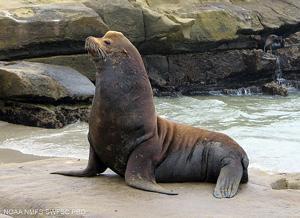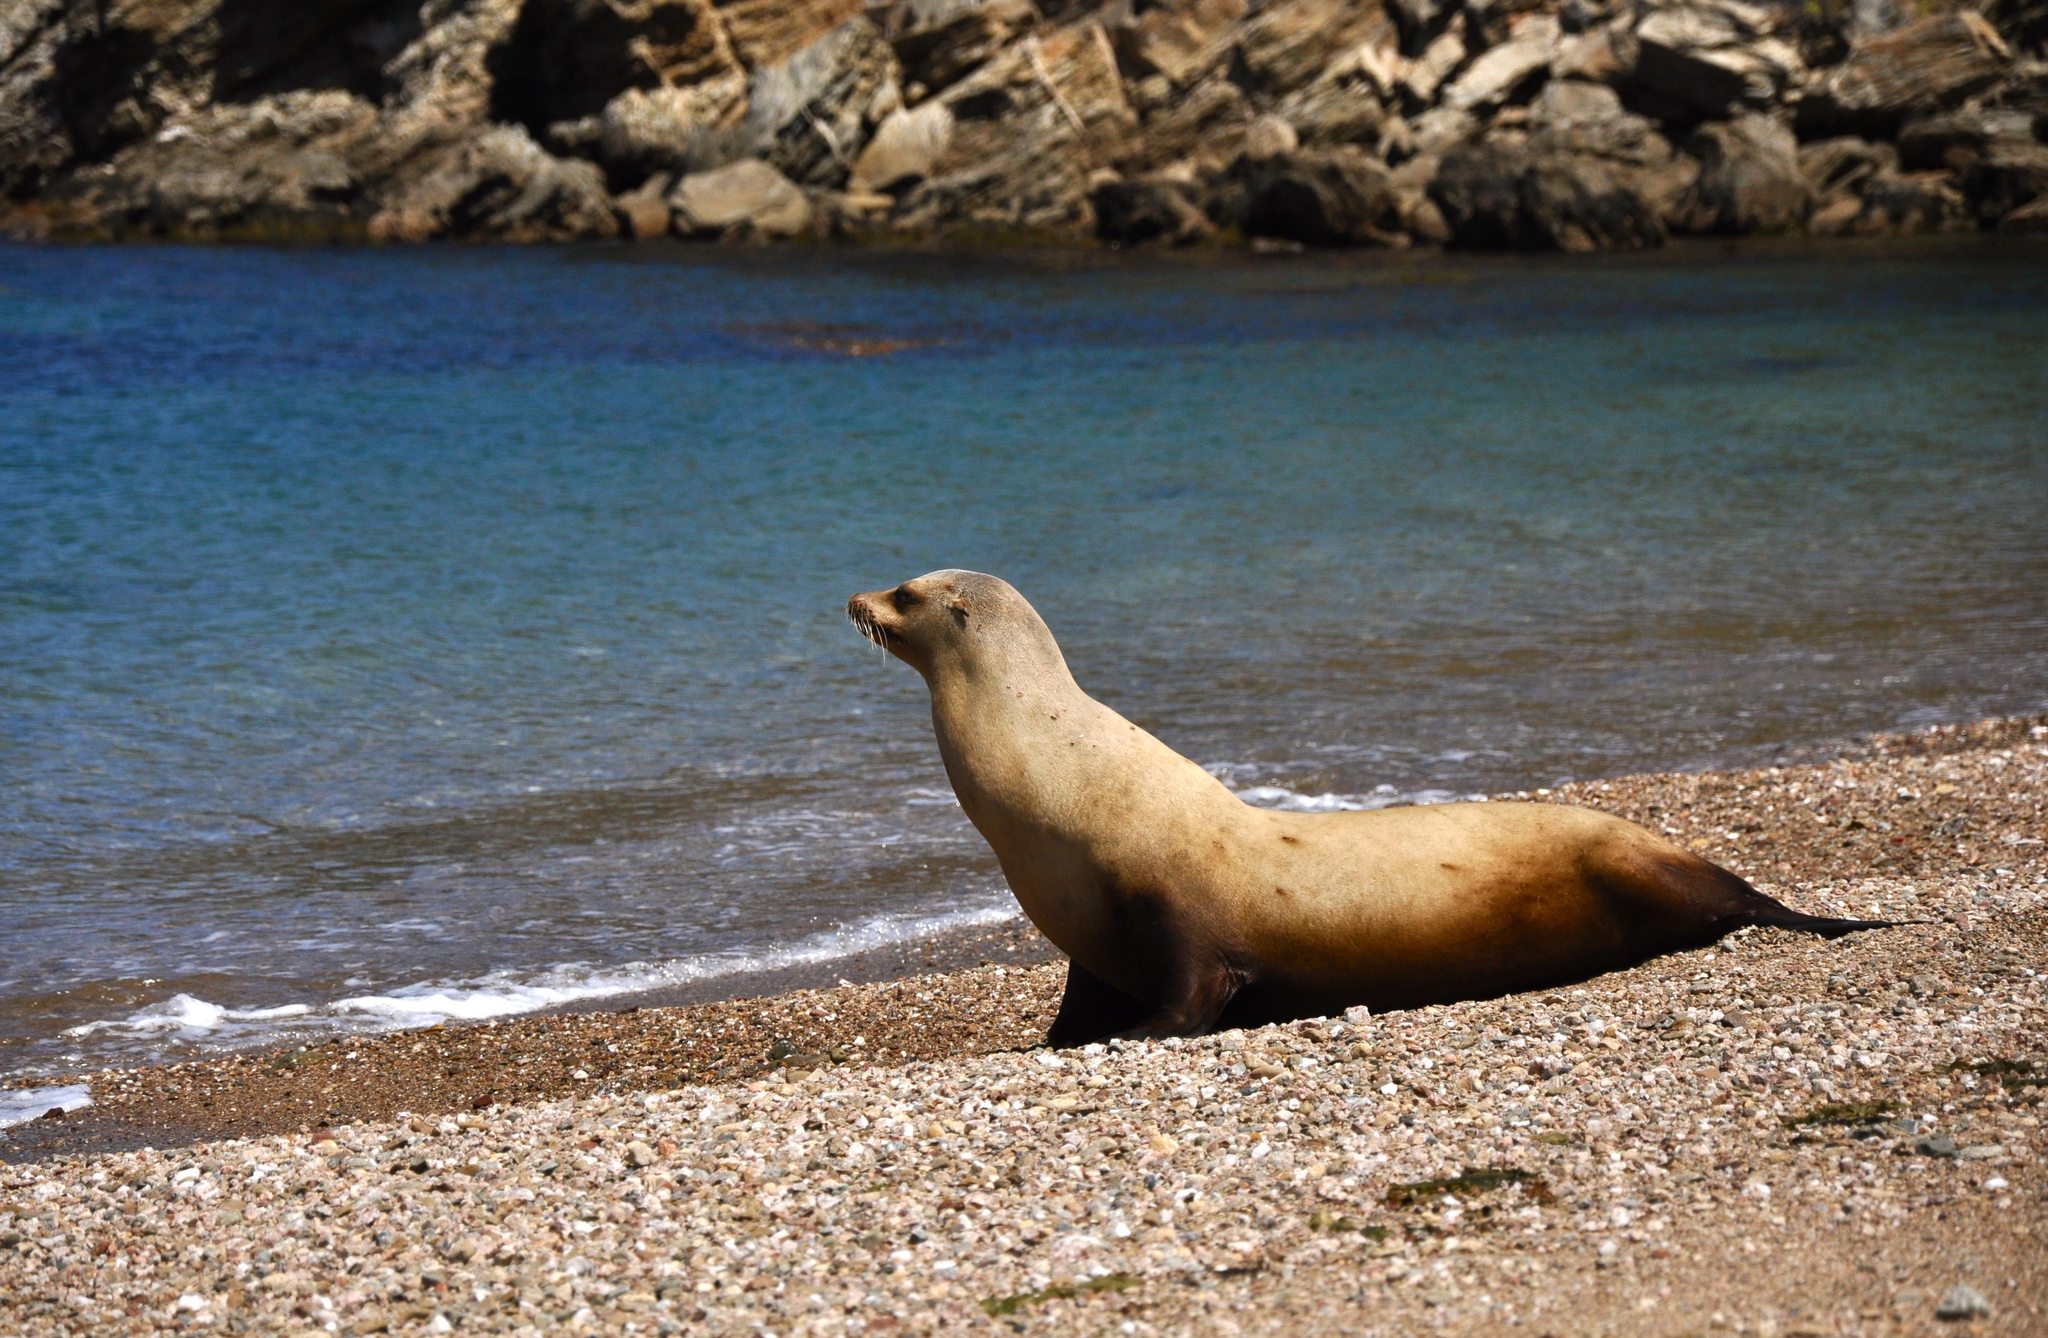The first image is the image on the left, the second image is the image on the right. Given the left and right images, does the statement "There are two seals" hold true? Answer yes or no. Yes. 